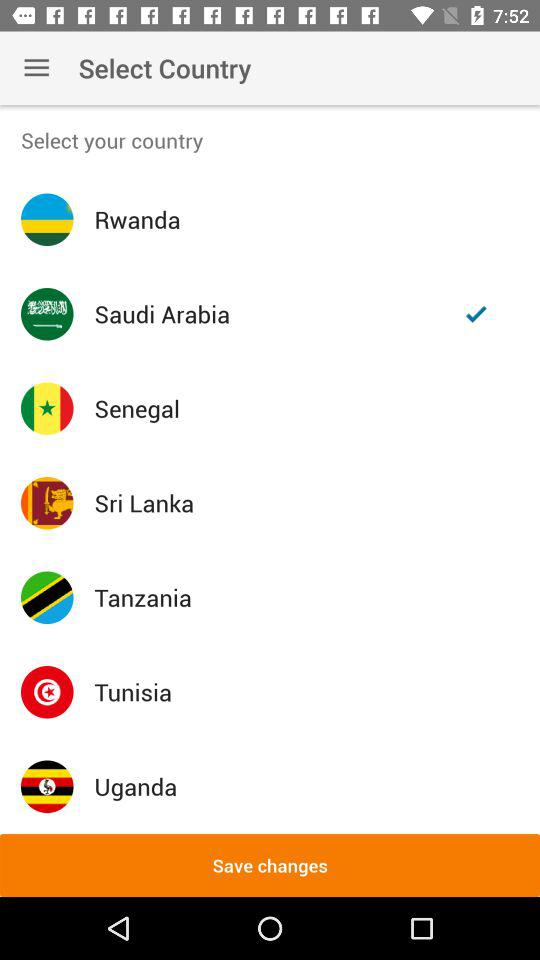Which is the selected country? The selected country is Saudi Arabia. 